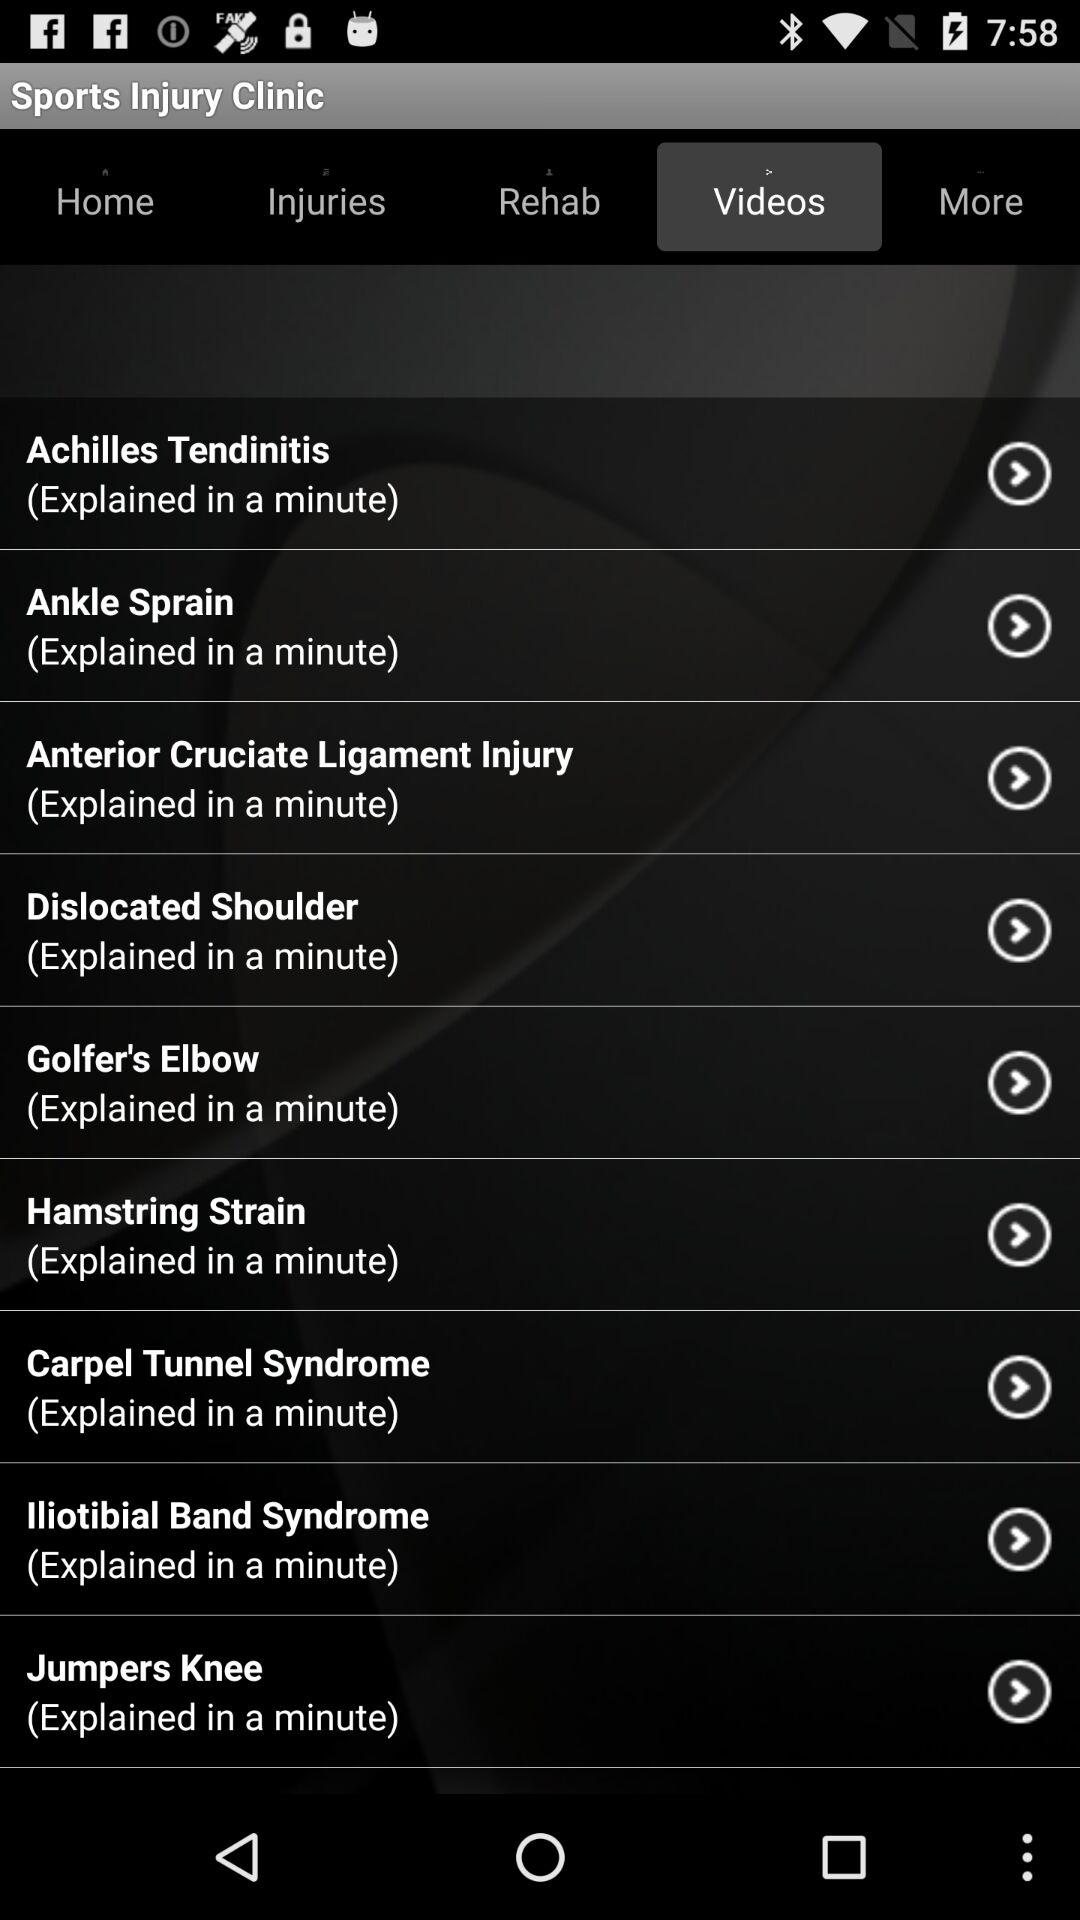Which tab is selected? The selected tab is "Videos". 